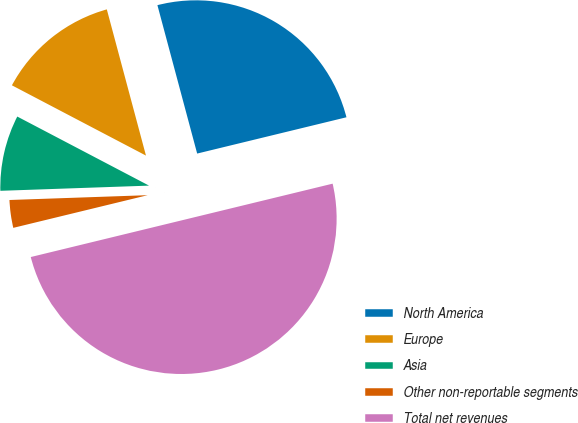Convert chart. <chart><loc_0><loc_0><loc_500><loc_500><pie_chart><fcel>North America<fcel>Europe<fcel>Asia<fcel>Other non-reportable segments<fcel>Total net revenues<nl><fcel>25.37%<fcel>13.15%<fcel>8.24%<fcel>3.24%<fcel>50.0%<nl></chart> 